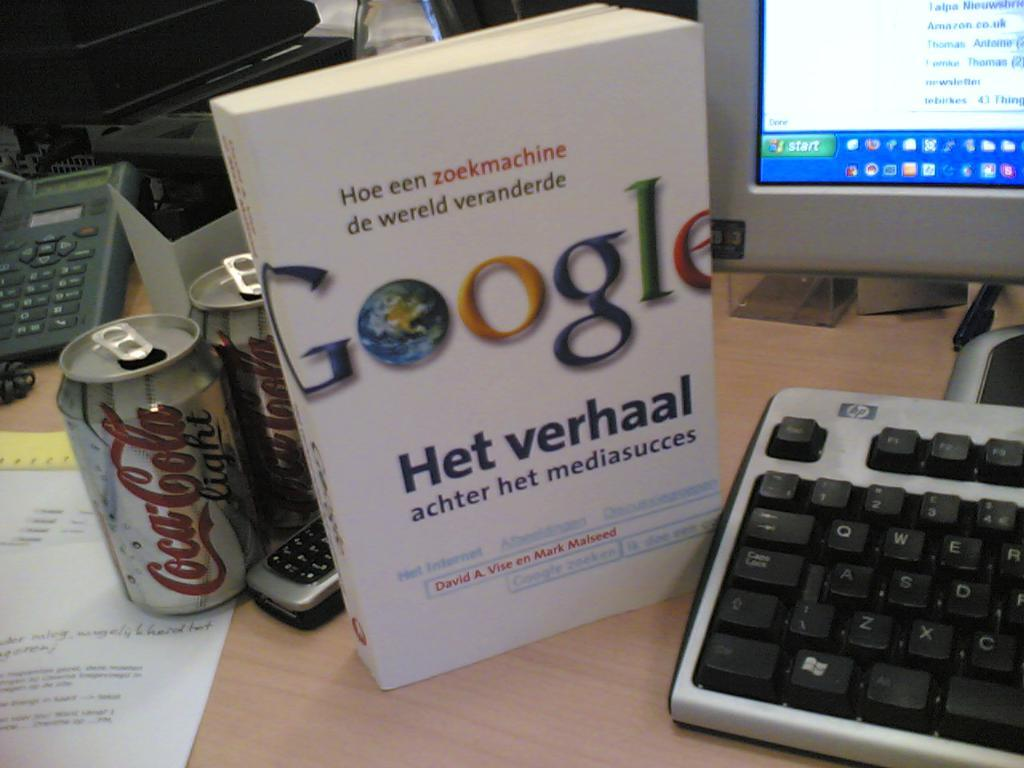<image>
Describe the image concisely. A computer with what appears to be a user manual for Google, but i do not know what it says. 